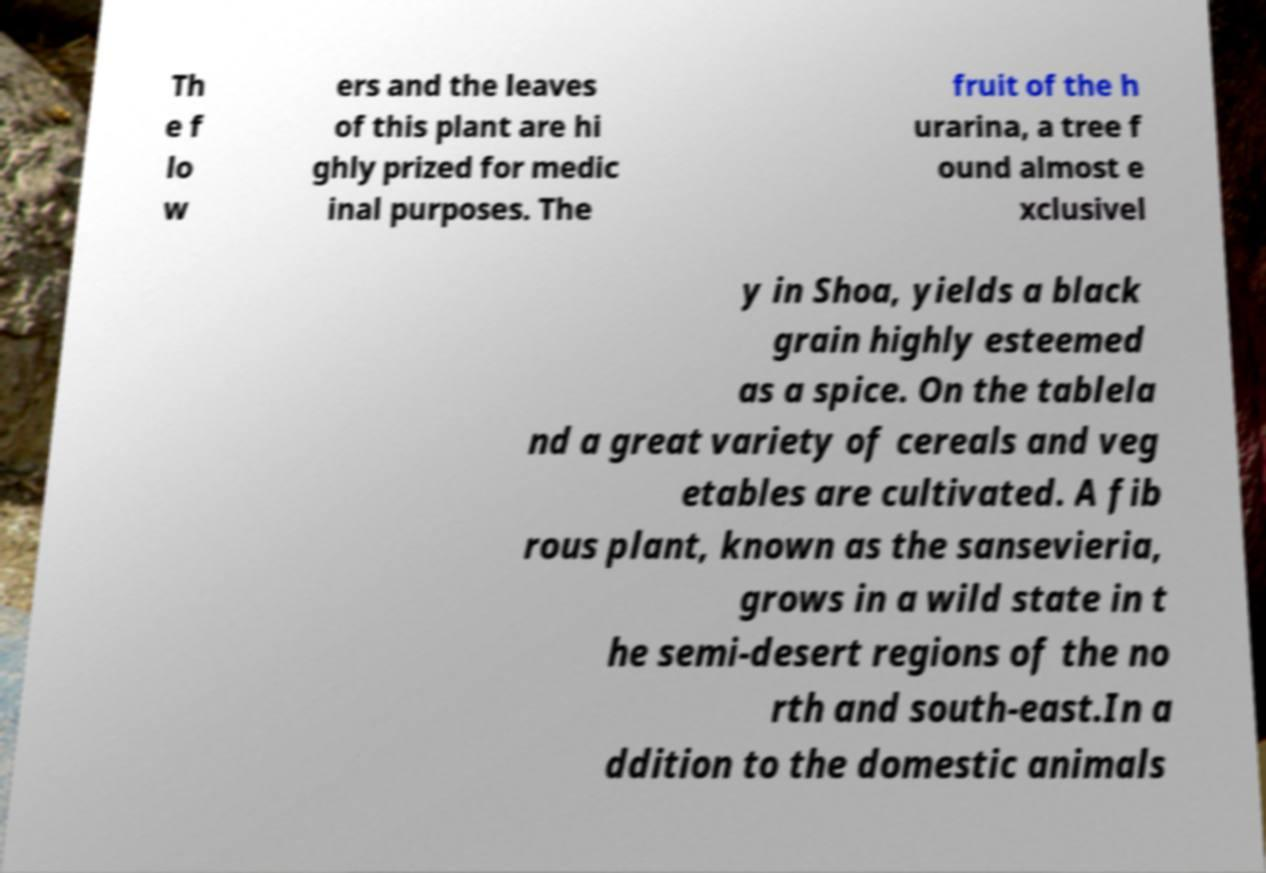Please read and relay the text visible in this image. What does it say? Th e f lo w ers and the leaves of this plant are hi ghly prized for medic inal purposes. The fruit of the h urarina, a tree f ound almost e xclusivel y in Shoa, yields a black grain highly esteemed as a spice. On the tablela nd a great variety of cereals and veg etables are cultivated. A fib rous plant, known as the sansevieria, grows in a wild state in t he semi-desert regions of the no rth and south-east.In a ddition to the domestic animals 